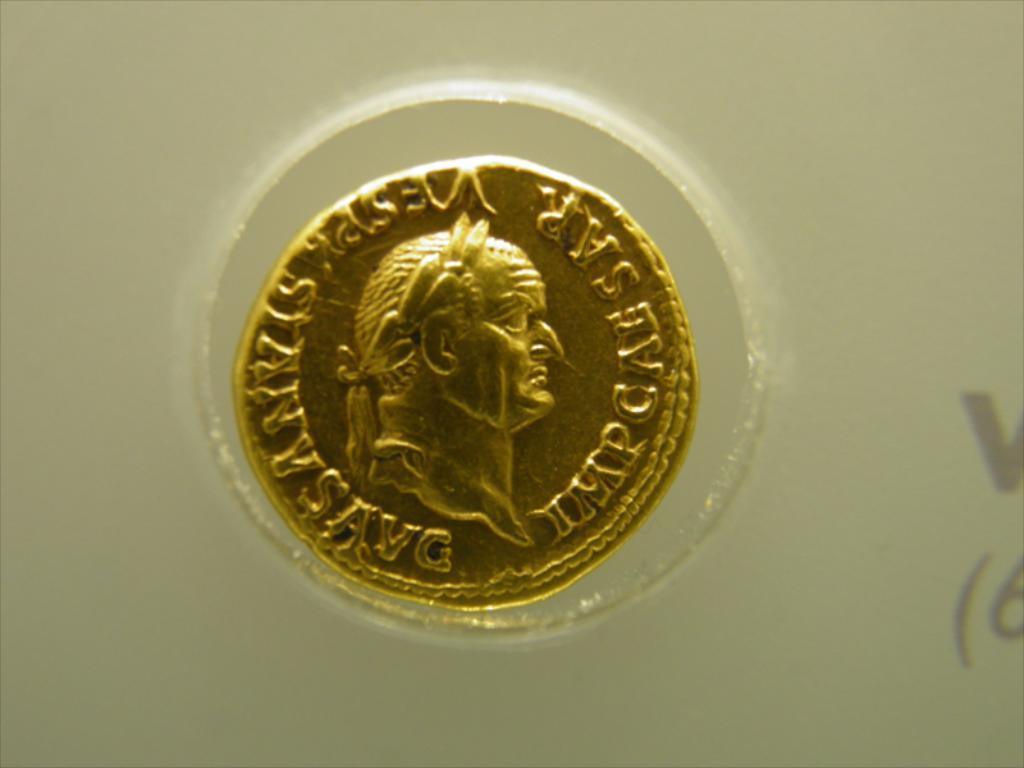<image>
Provide a brief description of the given image. a gold coin that says imp caesar on it 